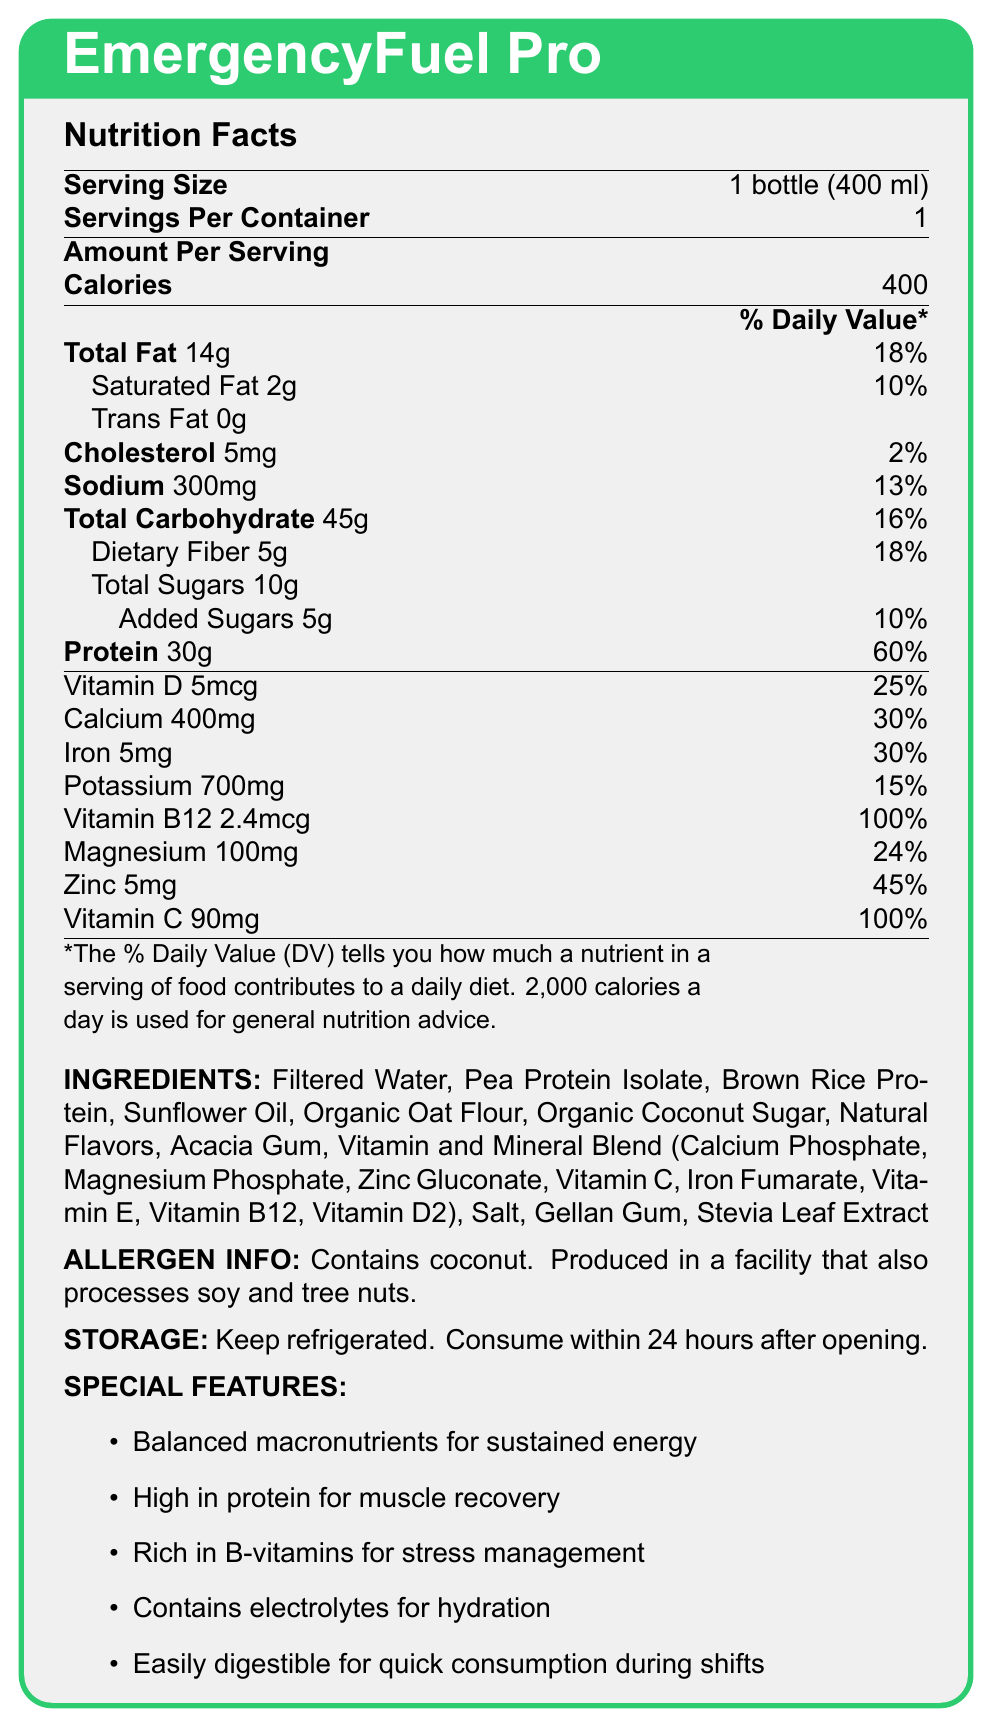what is the serving size for EmergencyFuel Pro? The serving size mentioned in the document is "1 bottle (400 ml)".
Answer: 1 bottle (400 ml) how many grams of protein does each serving of EmergencyFuel Pro contain? The document states that each serving contains 30 grams of protein.
Answer: 30g what percentage of the daily value of iron is provided by EmergencyFuel Pro? The iron content in the document is listed as 30% of the daily value.
Answer: 30% how many calories are in one serving of EmergencyFuel Pro? The document lists the calories per serving as 400.
Answer: 400 calories what are the primary sources of protein in EmergencyFuel Pro? The ingredients list includes Pea Protein Isolate and Brown Rice Protein as the main protein sources.
Answer: Pea Protein Isolate, Brown Rice Protein how much dietary fiber does EmergencyFuel Pro contain per serving? The document states that there are 5 grams of dietary fiber per serving.
Answer: 5g Does EmergencyFuel Pro contain any Vitamin D? A. Yes, 2.4mcg B. Yes, 5mcg C. No The document lists Vitamin D content as 5mcg per serving.
Answer: B. Yes, 5mcg how much added sugar is in one serving of EmergencyFuel Pro? A. 5g B. 10g C. 15g D. None The document states that there are 5 grams of added sugars in one serving.
Answer: A. 5g Is EmergencyFuel Pro gluten-free? The document does not provide information about whether it is gluten-free or contains gluten.
Answer: Not enough information does EmergencyFuel Pro need to be refrigerated? The storage instructions state, "Keep refrigerated".
Answer: Yes is EmergencyFuel Pro suitable for individuals with a tree nut allergy? The document mentions that it is produced in a facility that processes tree nuts, which could pose a risk for individuals with a tree nut allergy.
Answer: No summarize the main features of EmergencyFuel Pro This summary captures the primary purpose and key features of EmergencyFuel Pro as shared in the document.
Answer: EmergencyFuel Pro is a nutrient-dense meal replacement shake designed for emergency responders. It offers balanced macronutrients, high protein content, B-vitamins for stress management, electrolytes for hydration, and is easily digestible for quick consumption during shifts. what is the primary fat source listed in the ingredients of EmergencyFuel Pro? The ingredients list Sunflower Oil as one of the main sources of fat.
Answer: Sunflower Oil what percentage of the daily value for Vitamin B12 does one serving of EmergencyFuel Pro provide? The document states that one serving provides 100% of the daily value for Vitamin B12.
Answer: 100% describe the special features of EmergencyFuel Pro. The special features section of the document outlines these key attributes.
Answer: EmergencyFuel Pro offers balanced macronutrients for sustained energy, high protein for muscle recovery, B-vitamins for stress management, electrolytes for hydration, and is easily digestible for quick consumption during shifts. how much sodium does EmergencyFuel Pro contain per serving? The sodium content per serving is listed as 300mg in the document.
Answer: 300mg 